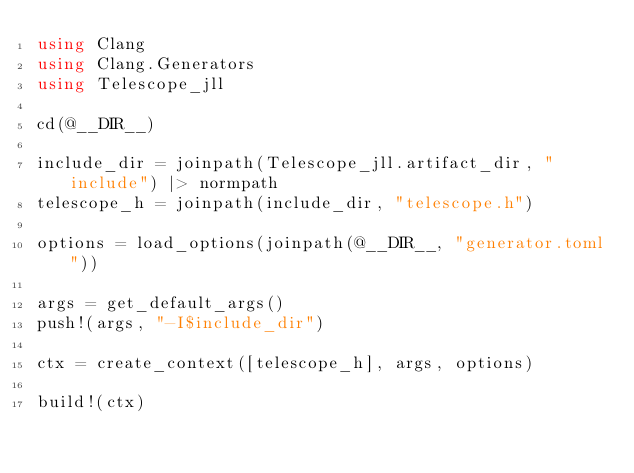<code> <loc_0><loc_0><loc_500><loc_500><_Julia_>using Clang
using Clang.Generators
using Telescope_jll

cd(@__DIR__)

include_dir = joinpath(Telescope_jll.artifact_dir, "include") |> normpath
telescope_h = joinpath(include_dir, "telescope.h")

options = load_options(joinpath(@__DIR__, "generator.toml"))

args = get_default_args()
push!(args, "-I$include_dir")

ctx = create_context([telescope_h], args, options)

build!(ctx)</code> 